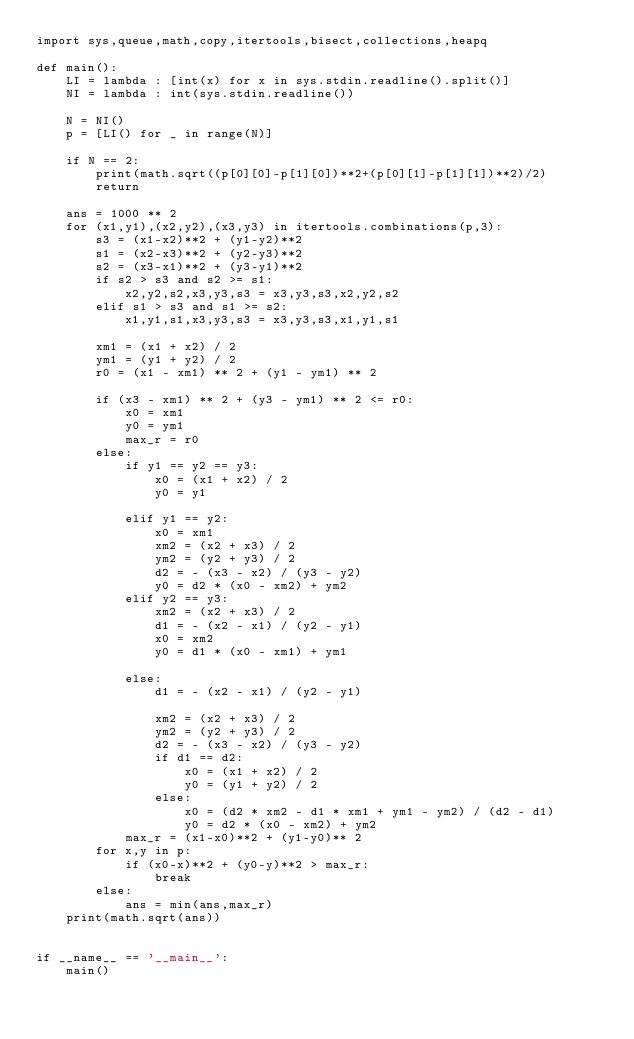<code> <loc_0><loc_0><loc_500><loc_500><_Python_>import sys,queue,math,copy,itertools,bisect,collections,heapq

def main():
    LI = lambda : [int(x) for x in sys.stdin.readline().split()]
    NI = lambda : int(sys.stdin.readline())

    N = NI()
    p = [LI() for _ in range(N)]

    if N == 2:
        print(math.sqrt((p[0][0]-p[1][0])**2+(p[0][1]-p[1][1])**2)/2)
        return

    ans = 1000 ** 2
    for (x1,y1),(x2,y2),(x3,y3) in itertools.combinations(p,3):
        s3 = (x1-x2)**2 + (y1-y2)**2
        s1 = (x2-x3)**2 + (y2-y3)**2
        s2 = (x3-x1)**2 + (y3-y1)**2
        if s2 > s3 and s2 >= s1:
            x2,y2,s2,x3,y3,s3 = x3,y3,s3,x2,y2,s2
        elif s1 > s3 and s1 >= s2:
            x1,y1,s1,x3,y3,s3 = x3,y3,s3,x1,y1,s1

        xm1 = (x1 + x2) / 2
        ym1 = (y1 + y2) / 2
        r0 = (x1 - xm1) ** 2 + (y1 - ym1) ** 2

        if (x3 - xm1) ** 2 + (y3 - ym1) ** 2 <= r0:
            x0 = xm1
            y0 = ym1
            max_r = r0
        else:
            if y1 == y2 == y3:
                x0 = (x1 + x2) / 2
                y0 = y1

            elif y1 == y2:
                x0 = xm1
                xm2 = (x2 + x3) / 2
                ym2 = (y2 + y3) / 2
                d2 = - (x3 - x2) / (y3 - y2)
                y0 = d2 * (x0 - xm2) + ym2
            elif y2 == y3:
                xm2 = (x2 + x3) / 2
                d1 = - (x2 - x1) / (y2 - y1)
                x0 = xm2
                y0 = d1 * (x0 - xm1) + ym1

            else:
                d1 = - (x2 - x1) / (y2 - y1)

                xm2 = (x2 + x3) / 2
                ym2 = (y2 + y3) / 2
                d2 = - (x3 - x2) / (y3 - y2)
                if d1 == d2:
                    x0 = (x1 + x2) / 2
                    y0 = (y1 + y2) / 2
                else:
                    x0 = (d2 * xm2 - d1 * xm1 + ym1 - ym2) / (d2 - d1)
                    y0 = d2 * (x0 - xm2) + ym2
            max_r = (x1-x0)**2 + (y1-y0)** 2
        for x,y in p:
            if (x0-x)**2 + (y0-y)**2 > max_r:
                break
        else:
            ans = min(ans,max_r)
    print(math.sqrt(ans))


if __name__ == '__main__':
    main()</code> 